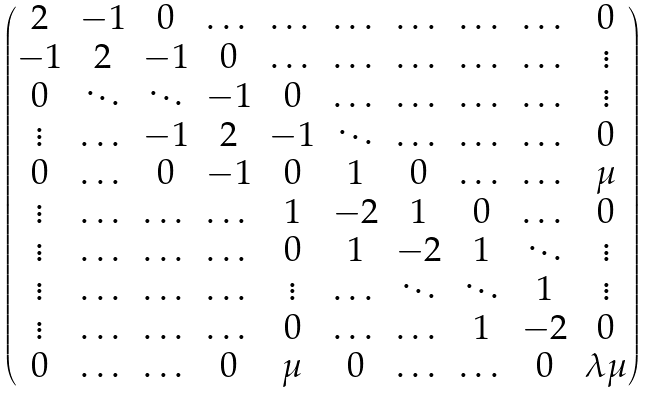Convert formula to latex. <formula><loc_0><loc_0><loc_500><loc_500>\begin{pmatrix} 2 & - 1 & 0 & \dots & \dots & \dots & \dots & \dots & \dots & 0 \\ - 1 & 2 & - 1 & 0 & \dots & \dots & \dots & \dots & \dots & \vdots \\ 0 & \ddots & \ddots & - 1 & 0 & \dots & \dots & \dots & \dots & \vdots \\ \vdots & \dots & - 1 & 2 & - 1 & \ddots & \dots & \dots & \dots & 0 \\ 0 & \dots & 0 & - 1 & 0 & 1 & 0 & \dots & \dots & \mu \\ \vdots & \dots & \dots & \dots & 1 & - 2 & 1 & 0 & \dots & 0 \\ \vdots & \dots & \dots & \dots & 0 & 1 & - 2 & 1 & \ddots & \vdots \\ \vdots & \dots & \dots & \dots & \vdots & \dots & \ddots & \ddots & 1 & \vdots \\ \vdots & \dots & \dots & \dots & 0 & \dots & \dots & 1 & - 2 & 0 \\ 0 & \dots & \dots & 0 & \mu & 0 & \dots & \dots & 0 & \lambda \mu \end{pmatrix}</formula> 